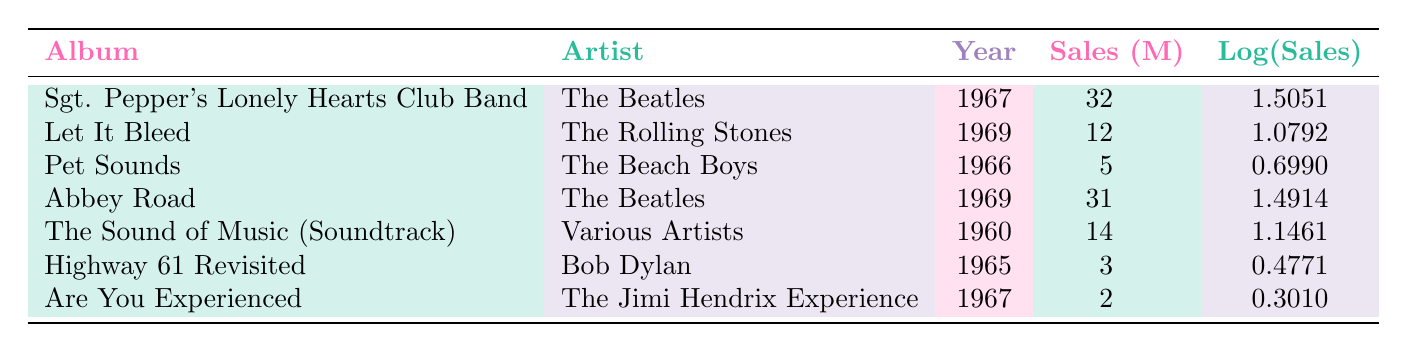What is the highest-selling album of the 1960s according to the table? The highest-selling album can be identified by comparing the sales figures across all rows. "Sgt. Pepper's Lonely Hearts Club Band" has the highest sales at 32 million.
Answer: 32 million Which artist released two of the top-selling albums in the 1960s? By inspecting the table, The Beatles appear twice with "Sgt. Pepper's Lonely Hearts Club Band" and "Abbey Road." They are the only artist with two entries listed.
Answer: Yes What is the total sales of albums released by The Beatles? The total sales from rows associated with The Beatles are 32 million (from "Sgt. Pepper's Lonely Hearts Club Band") and 31 million (from "Abbey Road"), totaling 63 million.
Answer: 63 million Is "Pet Sounds" by The Beach Boys more popular than "Highway 61 Revisited" by Bob Dylan based on sales? Comparing sales figures, "Pet Sounds" has 5 million while "Highway 61 Revisited" has only 3 million. Therefore, "Pet Sounds" is more popular.
Answer: Yes What is the average sales figure of the albums listed in the table? To find the average, add the sales amounts: 32 + 12 + 5 + 31 + 14 + 3 + 2 = 99 million. There are 7 albums, so the average is 99 / 7, which equals approximately 14.14 million.
Answer: 14.14 million 